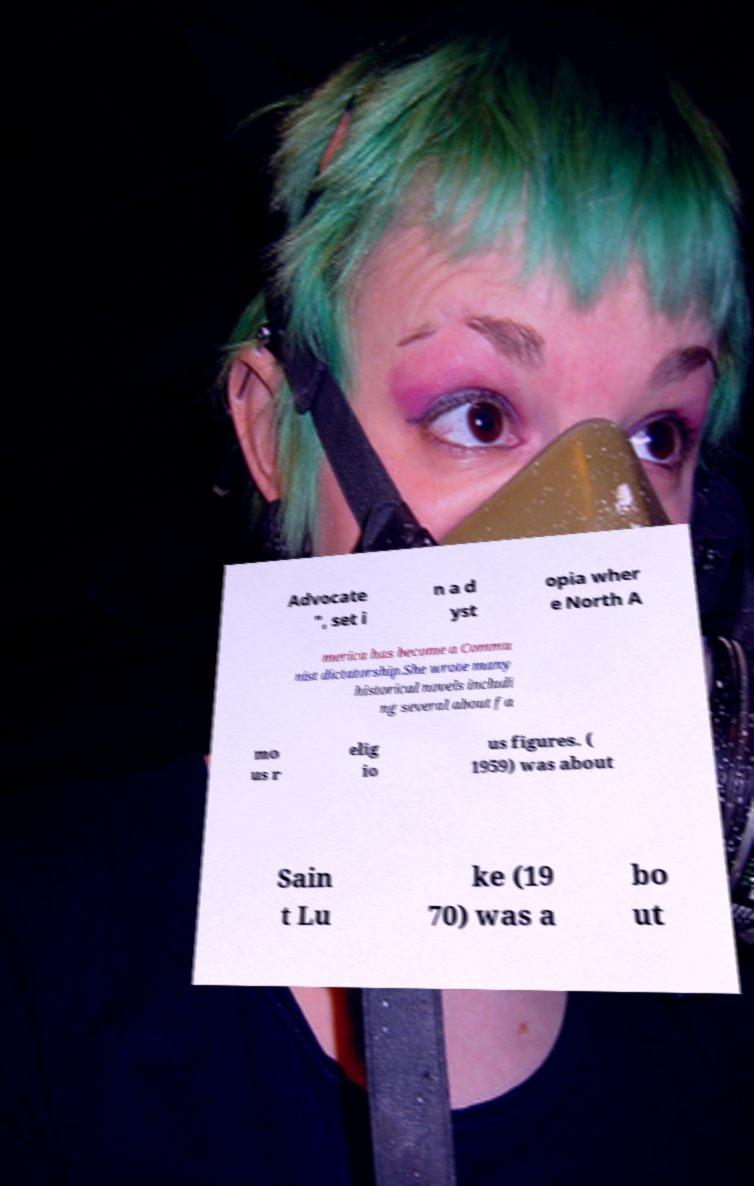Can you accurately transcribe the text from the provided image for me? Advocate ", set i n a d yst opia wher e North A merica has become a Commu nist dictatorship.She wrote many historical novels includi ng several about fa mo us r elig io us figures. ( 1959) was about Sain t Lu ke (19 70) was a bo ut 